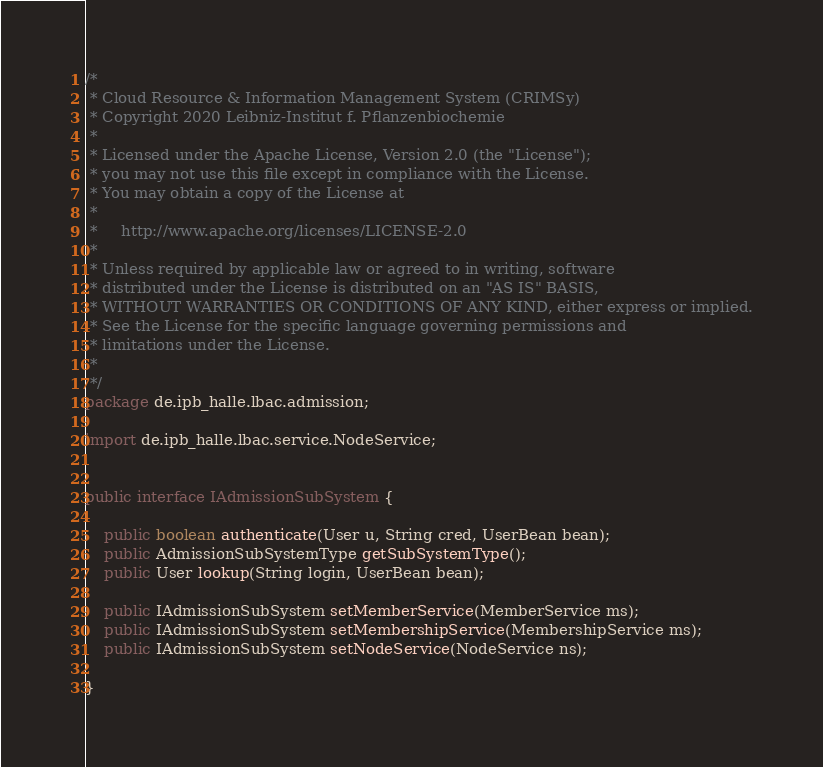Convert code to text. <code><loc_0><loc_0><loc_500><loc_500><_Java_>/*
 * Cloud Resource & Information Management System (CRIMSy)
 * Copyright 2020 Leibniz-Institut f. Pflanzenbiochemie
 *
 * Licensed under the Apache License, Version 2.0 (the "License");
 * you may not use this file except in compliance with the License.
 * You may obtain a copy of the License at
 *
 *     http://www.apache.org/licenses/LICENSE-2.0
 *
 * Unless required by applicable law or agreed to in writing, software
 * distributed under the License is distributed on an "AS IS" BASIS,
 * WITHOUT WARRANTIES OR CONDITIONS OF ANY KIND, either express or implied.
 * See the License for the specific language governing permissions and
 * limitations under the License.
 *
 */
package de.ipb_halle.lbac.admission;

import de.ipb_halle.lbac.service.NodeService;


public interface IAdmissionSubSystem {

    public boolean authenticate(User u, String cred, UserBean bean);
    public AdmissionSubSystemType getSubSystemType();
    public User lookup(String login, UserBean bean);

    public IAdmissionSubSystem setMemberService(MemberService ms);
    public IAdmissionSubSystem setMembershipService(MembershipService ms);
    public IAdmissionSubSystem setNodeService(NodeService ns);

}

</code> 